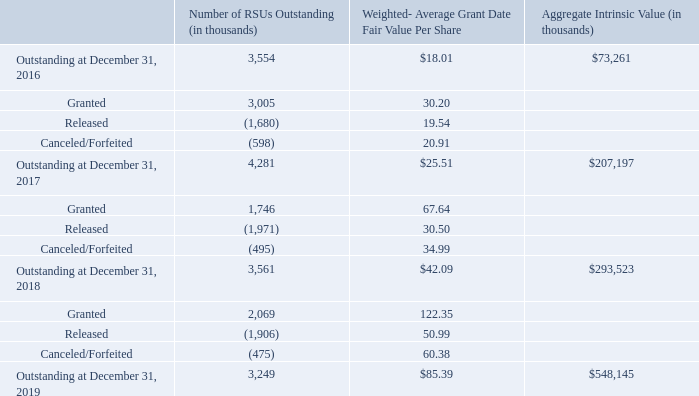Restricted Stock Units
The 2013 Plan provides for the issuance of RSUs to employees, directors, and consultants. RSUs issued under the 2013 Plan generally vest over four years. A summary of activity of RSUs under the 2013 Plan at December 31, 2019 and changes during the periods then ended is presented in the following table:
As of December 31, 2019 and 2018, there was a total of $198.3 million and $107.9 million of unrecognized share-based compensation expense, net of estimated forfeitures, related to RSUs, which will be recognized on a straight-line basis over the remaining weighted-average vesting periods of approximately 2.3 years and 2.4 years, respectively.
How many years do the RSUs issued under the 2013 Plan generally vest over? Four years. As of December 31 2019 and 2018, what are the respective values of unrecognized share-based compensation expense, net of estimated forfeitures, related to RSUs? $198.3 million, $107.9 million. As of December 31, 2019 and 2018, what are the respective remaining weighted-average vesting periods of  unrecognized share-based compensation expense, net of estimated forfeitures, related to RSUs? 2.3 years, 2.4 years. What is the percentage change in outstanding RSUs between December 31, 2016 and December 31, 2017?
Answer scale should be: percent. (4,281 - 3,554)/3,554 
Answer: 20.46. What is the percentage change in outstanding RSUs between December 31, 2017 and December 31, 2018?
Answer scale should be: percent. (3,561 - 4,281)/4,281 
Answer: -16.82. What is the percentage of granted RSUs as a percentage of outstanding RSUs at December 2016?
Answer scale should be: percent. (3,005/3,554) 
Answer: 84.55. 